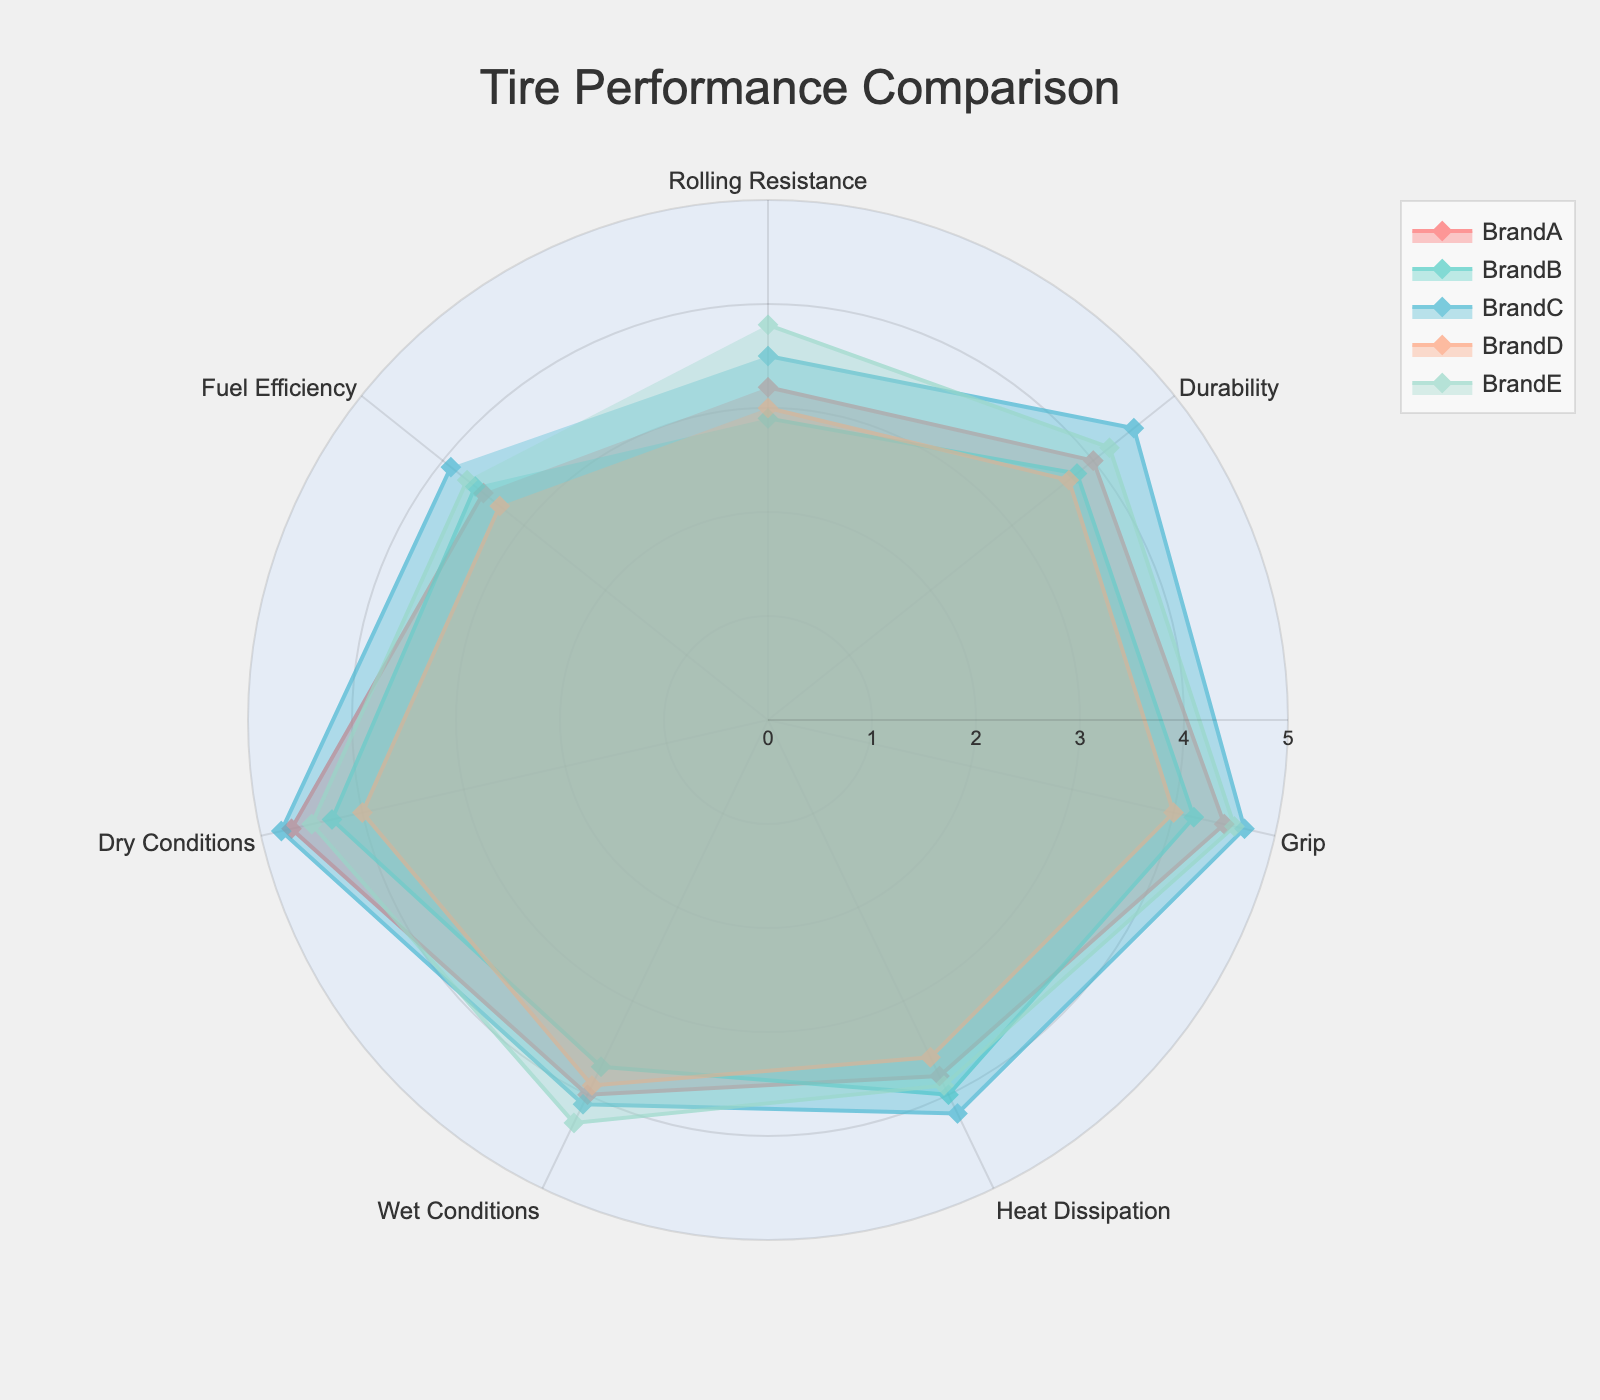Which tire brand has the highest rolling resistance? To identify the tire brand with the highest rolling resistance, look at the points plotted on the "Rolling Resistance" axis for each brand. The highest value on this axis corresponds to the brand with the highest rolling resistance.
Answer: Brand E Which tire brand has the best durability? To determine the tire brand with the best durability, examine the points on the "Durability" axis. The brand with the highest value on this axis has the best durability.
Answer: Brand C Which aspect does Brand B excel in compared to other brands? To find the aspect where Brand B excels, analyze each aspect's axis and compare Brand B's values with those of other brands. The aspect where Brand B has the highest relative value indicates its strength.
Answer: Heat Dissipation What is the average grip rating across all brands? Add the grip ratings for all brands and then divide by the number of brands to find the average. (4.5 + 4.2 + 4.7 + 4.0 + 4.6) / 5 = 22 / 5 = 4.4
Answer: 4.4 Which two brands have the closest fuel efficiency ratings? Compare the values under the "Fuel Efficiency" axis for all brands. The two closest values are for Brand A (3.5) and Brand D (3.3).
Answer: Brand A and Brand D In which categories does Brand D outperform Brand A? Compare the values of Brand D and Brand A across all the categories/aspects. Brand D outperforms Brand A in Heat Dissipation and Wet Conditions.
Answer: Heat Dissipation, Wet Conditions Which brand has the most balanced performance across all aspects? A balanced performance means that the values of one brand are roughly consistent across all aspects. Reviewing the radar plot, Brand C appears to have consistent and high values across all aspects.
Answer: Brand C What is the range of the durability ratings across all brands? Identify the minimum and maximum durability ratings from the plot. Subtract the minimum value from the maximum value to get the range. Maximum is 4.5 (Brand C) and minimum is 3.7 (Brand D). Range is 4.5 - 3.7 = 0.8
Answer: 0.8 Which brand shows the largest disparity between its highest and lowest ratings? For each brand, calculate the difference between their highest and lowest aspect ratings. Brand D has the highest rating in Dry Conditions (4.0) and lowest in Rolling Resistance (3.0), so the disparity for Brand D is 4.0 - 3.0 = 1.0. Other brands have smaller disparities.
Answer: Brand D 